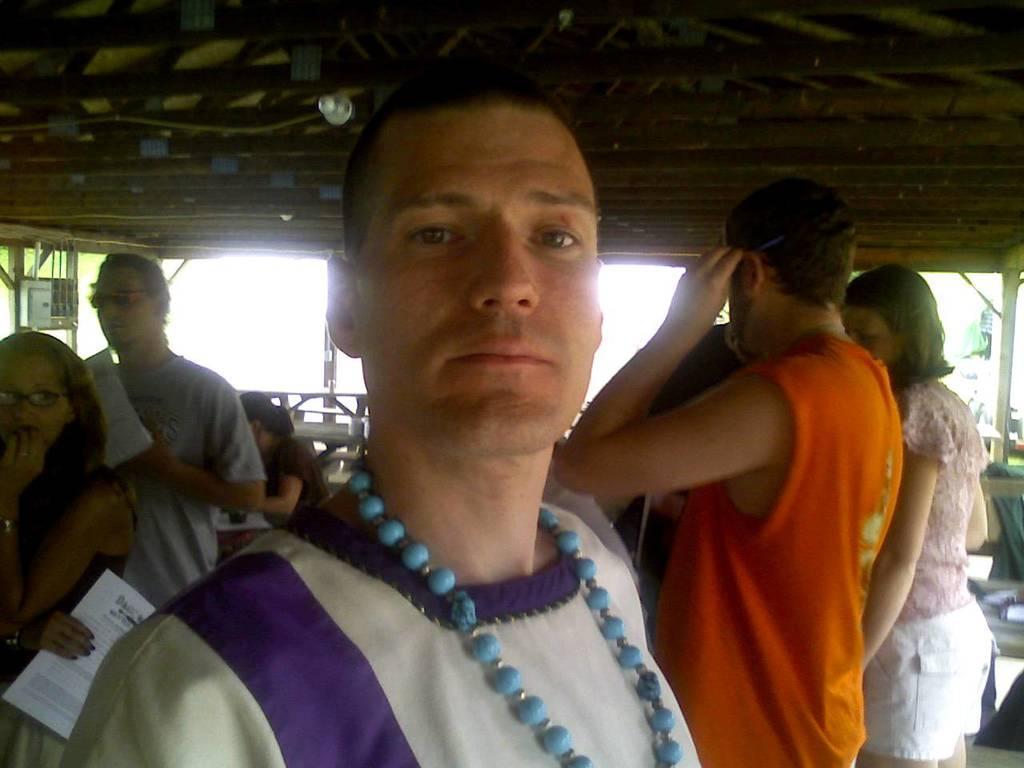In one or two sentences, can you explain what this image depicts? In this image, at the middle we can see a man standing and in the background there are some people standing, at the top there is a shed. 